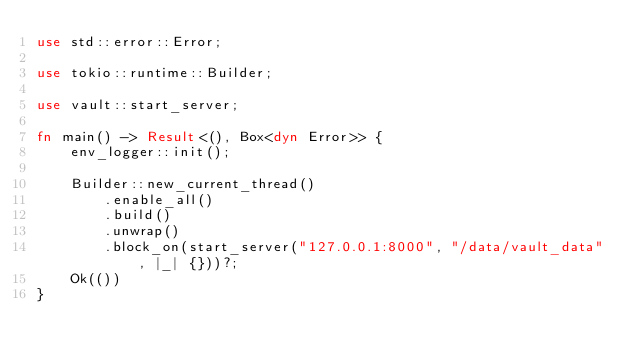Convert code to text. <code><loc_0><loc_0><loc_500><loc_500><_Rust_>use std::error::Error;

use tokio::runtime::Builder;

use vault::start_server;

fn main() -> Result<(), Box<dyn Error>> {
    env_logger::init();

    Builder::new_current_thread()
        .enable_all()
        .build()
        .unwrap()
        .block_on(start_server("127.0.0.1:8000", "/data/vault_data", |_| {}))?;
    Ok(())
}
</code> 